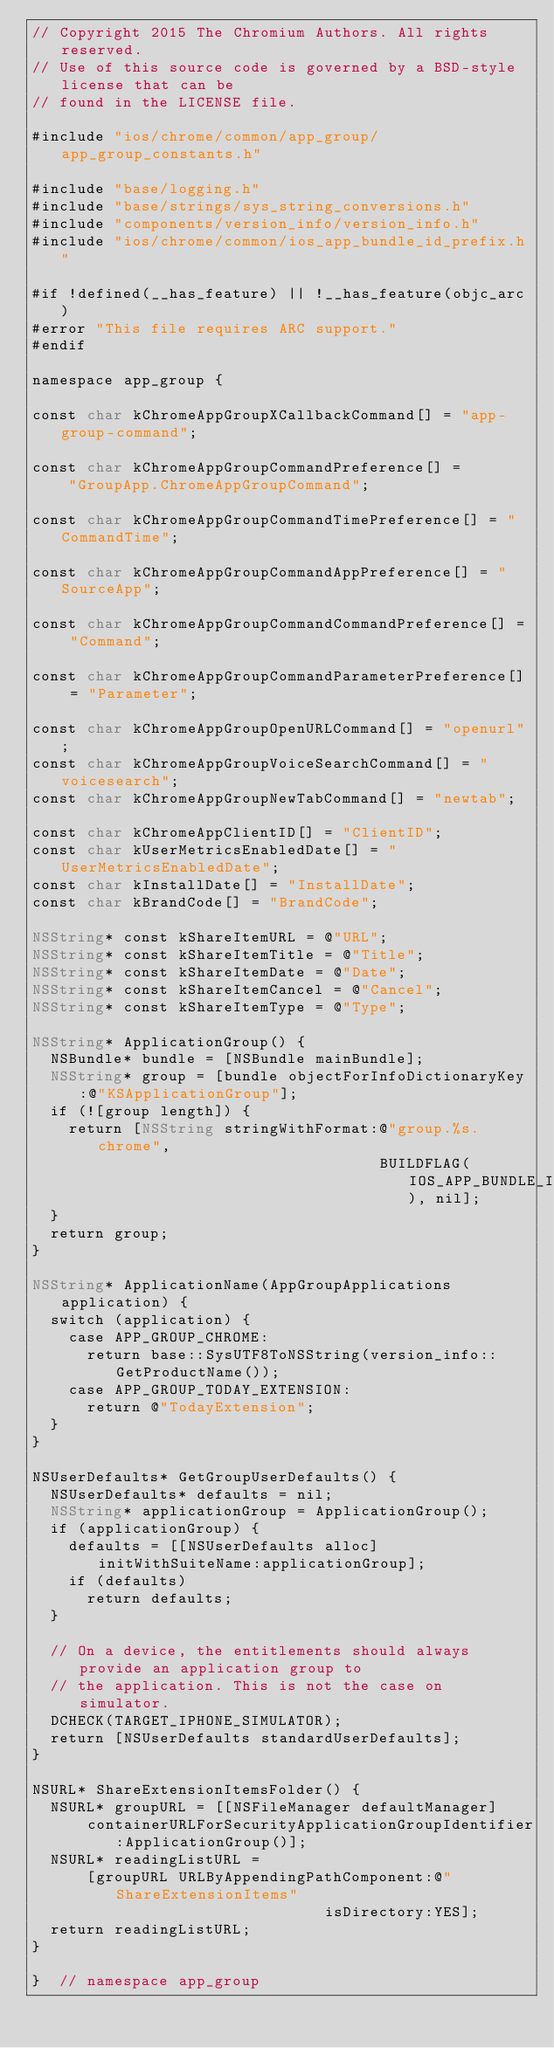<code> <loc_0><loc_0><loc_500><loc_500><_ObjectiveC_>// Copyright 2015 The Chromium Authors. All rights reserved.
// Use of this source code is governed by a BSD-style license that can be
// found in the LICENSE file.

#include "ios/chrome/common/app_group/app_group_constants.h"

#include "base/logging.h"
#include "base/strings/sys_string_conversions.h"
#include "components/version_info/version_info.h"
#include "ios/chrome/common/ios_app_bundle_id_prefix.h"

#if !defined(__has_feature) || !__has_feature(objc_arc)
#error "This file requires ARC support."
#endif

namespace app_group {

const char kChromeAppGroupXCallbackCommand[] = "app-group-command";

const char kChromeAppGroupCommandPreference[] =
    "GroupApp.ChromeAppGroupCommand";

const char kChromeAppGroupCommandTimePreference[] = "CommandTime";

const char kChromeAppGroupCommandAppPreference[] = "SourceApp";

const char kChromeAppGroupCommandCommandPreference[] = "Command";

const char kChromeAppGroupCommandParameterPreference[] = "Parameter";

const char kChromeAppGroupOpenURLCommand[] = "openurl";
const char kChromeAppGroupVoiceSearchCommand[] = "voicesearch";
const char kChromeAppGroupNewTabCommand[] = "newtab";

const char kChromeAppClientID[] = "ClientID";
const char kUserMetricsEnabledDate[] = "UserMetricsEnabledDate";
const char kInstallDate[] = "InstallDate";
const char kBrandCode[] = "BrandCode";

NSString* const kShareItemURL = @"URL";
NSString* const kShareItemTitle = @"Title";
NSString* const kShareItemDate = @"Date";
NSString* const kShareItemCancel = @"Cancel";
NSString* const kShareItemType = @"Type";

NSString* ApplicationGroup() {
  NSBundle* bundle = [NSBundle mainBundle];
  NSString* group = [bundle objectForInfoDictionaryKey:@"KSApplicationGroup"];
  if (![group length]) {
    return [NSString stringWithFormat:@"group.%s.chrome",
                                      BUILDFLAG(IOS_APP_BUNDLE_ID_PREFIX), nil];
  }
  return group;
}

NSString* ApplicationName(AppGroupApplications application) {
  switch (application) {
    case APP_GROUP_CHROME:
      return base::SysUTF8ToNSString(version_info::GetProductName());
    case APP_GROUP_TODAY_EXTENSION:
      return @"TodayExtension";
  }
}

NSUserDefaults* GetGroupUserDefaults() {
  NSUserDefaults* defaults = nil;
  NSString* applicationGroup = ApplicationGroup();
  if (applicationGroup) {
    defaults = [[NSUserDefaults alloc] initWithSuiteName:applicationGroup];
    if (defaults)
      return defaults;
  }

  // On a device, the entitlements should always provide an application group to
  // the application. This is not the case on simulator.
  DCHECK(TARGET_IPHONE_SIMULATOR);
  return [NSUserDefaults standardUserDefaults];
}

NSURL* ShareExtensionItemsFolder() {
  NSURL* groupURL = [[NSFileManager defaultManager]
      containerURLForSecurityApplicationGroupIdentifier:ApplicationGroup()];
  NSURL* readingListURL =
      [groupURL URLByAppendingPathComponent:@"ShareExtensionItems"
                                isDirectory:YES];
  return readingListURL;
}

}  // namespace app_group
</code> 